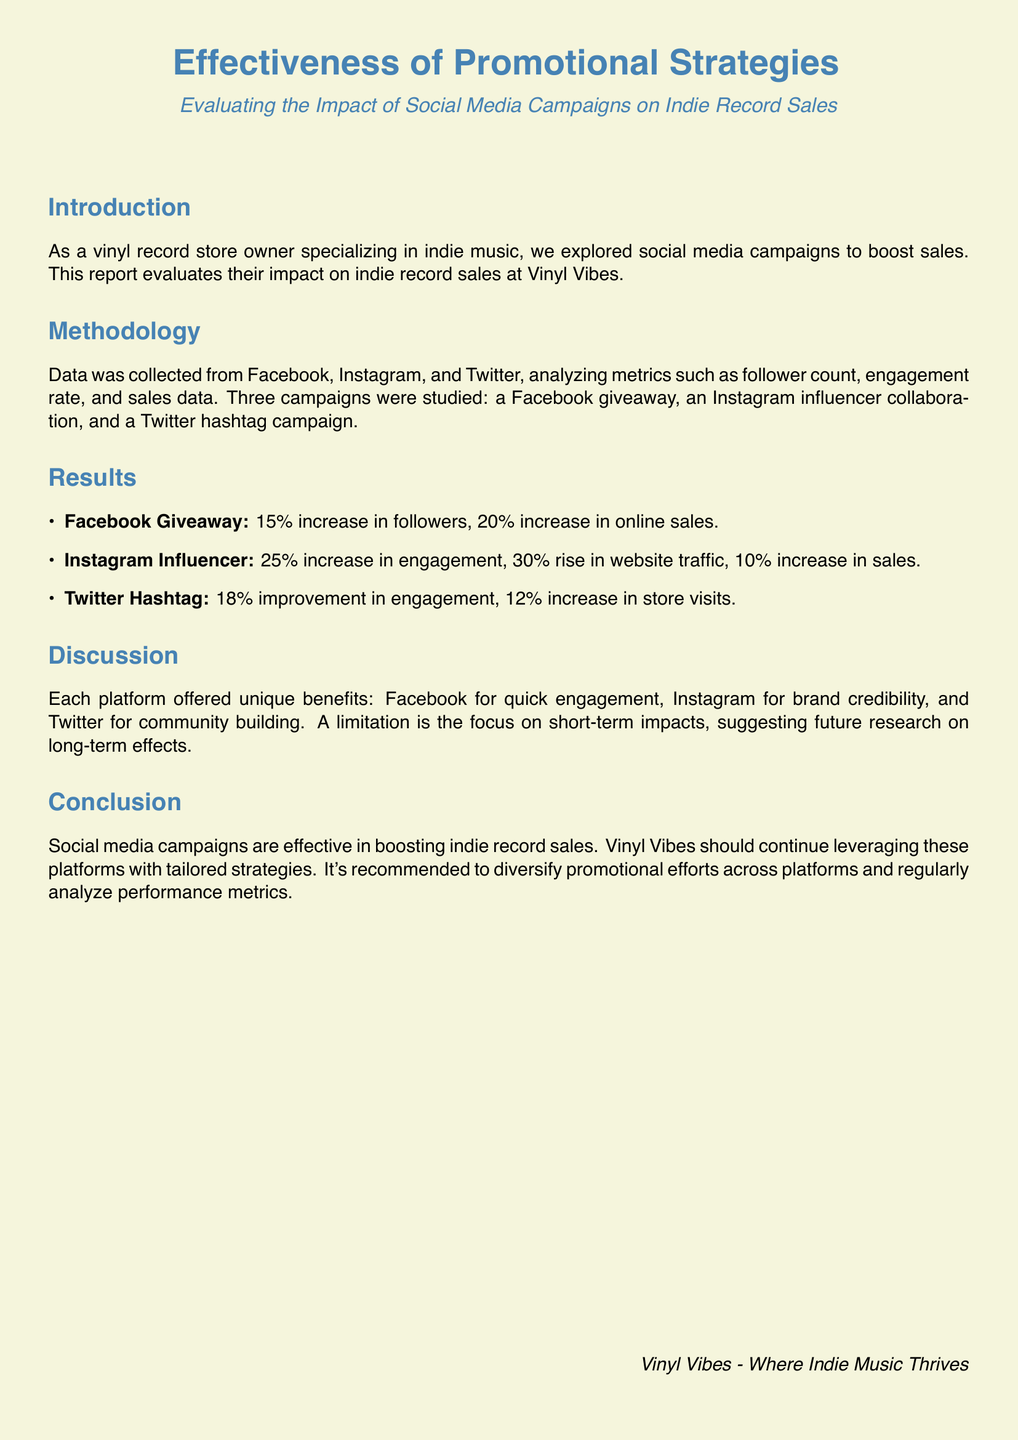What was the increase in online sales from the Facebook giveaway? The document states that there was a 20% increase in online sales from the Facebook giveaway.
Answer: 20% What was the primary benefit of the Instagram influencer campaign? The report indicates that the Instagram influencer campaign led to a 25% increase in engagement, highlighting its effectiveness in building brand credibility.
Answer: Brand credibility What does the Twitter hashtag campaign improve? According to the results, the Twitter hashtag campaign improved engagement by 18%.
Answer: Engagement What type of analysis was performed on the social media campaigns? The document mentions analyzing metrics such as follower count, engagement rate, and sales data.
Answer: Metrics What is suggested for future research in the discussion section? The discussion mentions a limitation in the focus on short-term impacts and suggests future research on long-term effects.
Answer: Long-term effects What store is the subject of this report? The report is about the Vinyl Vibes store.
Answer: Vinyl Vibes Which social media platform saw a 15% increase in followers? The results attribute a 15% increase in followers to the Facebook giveaway.
Answer: Facebook What is the conclusion about social media campaigns? The conclusion states that social media campaigns are effective in boosting indie record sales.
Answer: Effective What is the total increase in website traffic from the Instagram influencer campaign? The document specifies a 30% rise in website traffic due to the Instagram influencer campaign.
Answer: 30% 